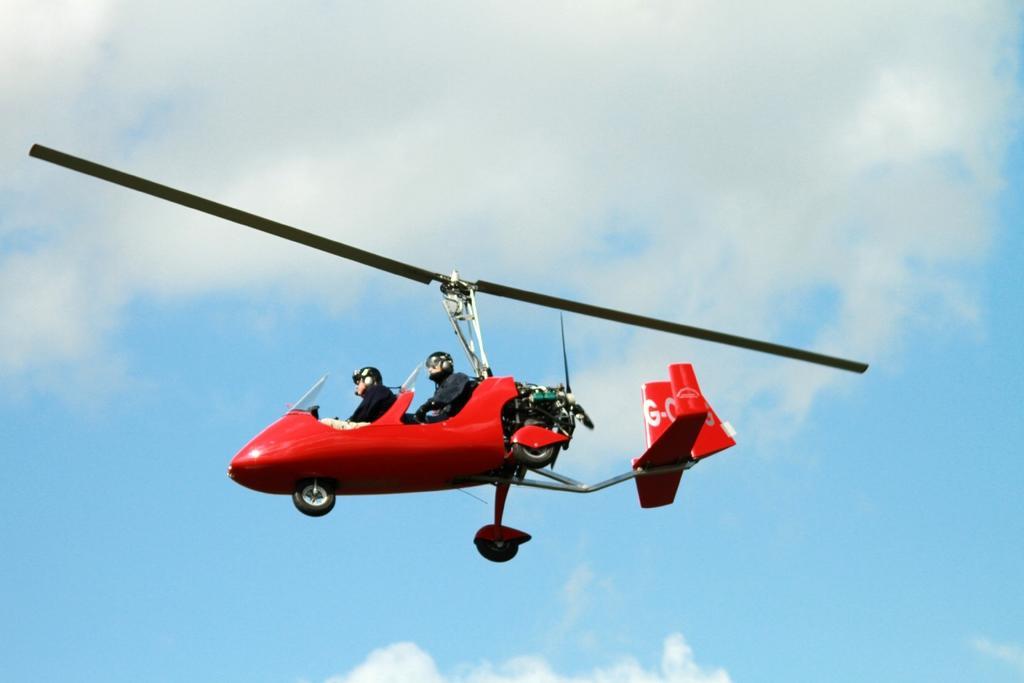In one or two sentences, can you explain what this image depicts? In this image we can see two people sitting in a helicopter which is flying in the sky. 